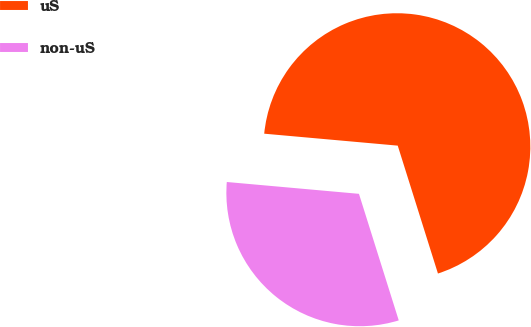Convert chart to OTSL. <chart><loc_0><loc_0><loc_500><loc_500><pie_chart><fcel>uS<fcel>non-uS<nl><fcel>68.73%<fcel>31.27%<nl></chart> 